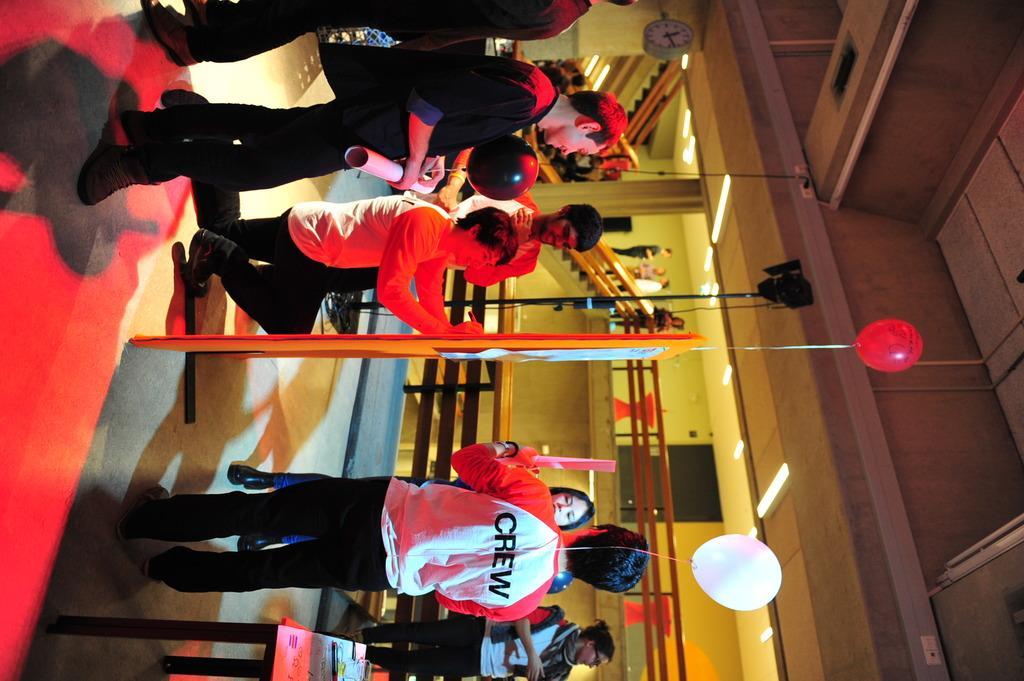Please provide a concise description of this image. In this image, there are a few people. We can see a pole and the ground with some objects. There are a few balloons. We can see a table with some objects. We can also see some stairs, the railing and the fence. We can also see some glass. We can also see the roof with some lights. 